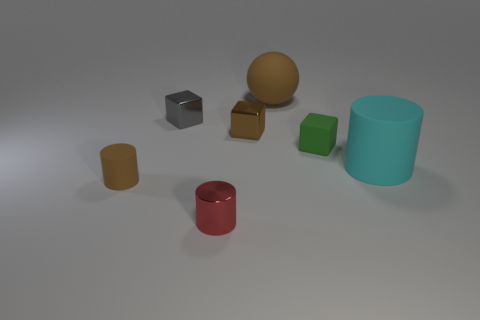How many other things are there of the same material as the red thing?
Ensure brevity in your answer.  2. There is a gray cube that is the same size as the red object; what is it made of?
Make the answer very short. Metal. Do the tiny matte object on the left side of the large brown matte sphere and the cyan rubber object have the same shape?
Make the answer very short. Yes. Is the color of the rubber block the same as the big rubber sphere?
Your answer should be very brief. No. What number of objects are either things that are in front of the small brown matte cylinder or big yellow spheres?
Your answer should be compact. 1. There is a red metallic object that is the same size as the gray object; what is its shape?
Your answer should be compact. Cylinder. Does the rubber cylinder that is in front of the large cyan cylinder have the same size as the shiny block to the right of the small gray shiny cube?
Make the answer very short. Yes. The other block that is the same material as the brown block is what color?
Provide a succinct answer. Gray. Is the small cylinder right of the tiny brown rubber cylinder made of the same material as the tiny block left of the tiny red thing?
Provide a short and direct response. Yes. Is there a matte sphere of the same size as the brown rubber cylinder?
Provide a short and direct response. No. 